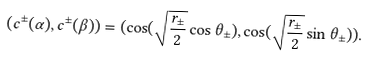<formula> <loc_0><loc_0><loc_500><loc_500>( c ^ { \pm } ( \alpha ) , c ^ { \pm } ( \beta ) ) = ( \cos ( \sqrt { \frac { r _ { \pm } } { 2 } } \cos \theta _ { \pm } ) , \cos ( \sqrt { \frac { r _ { \pm } } { 2 } } \sin \theta _ { \pm } ) ) .</formula> 